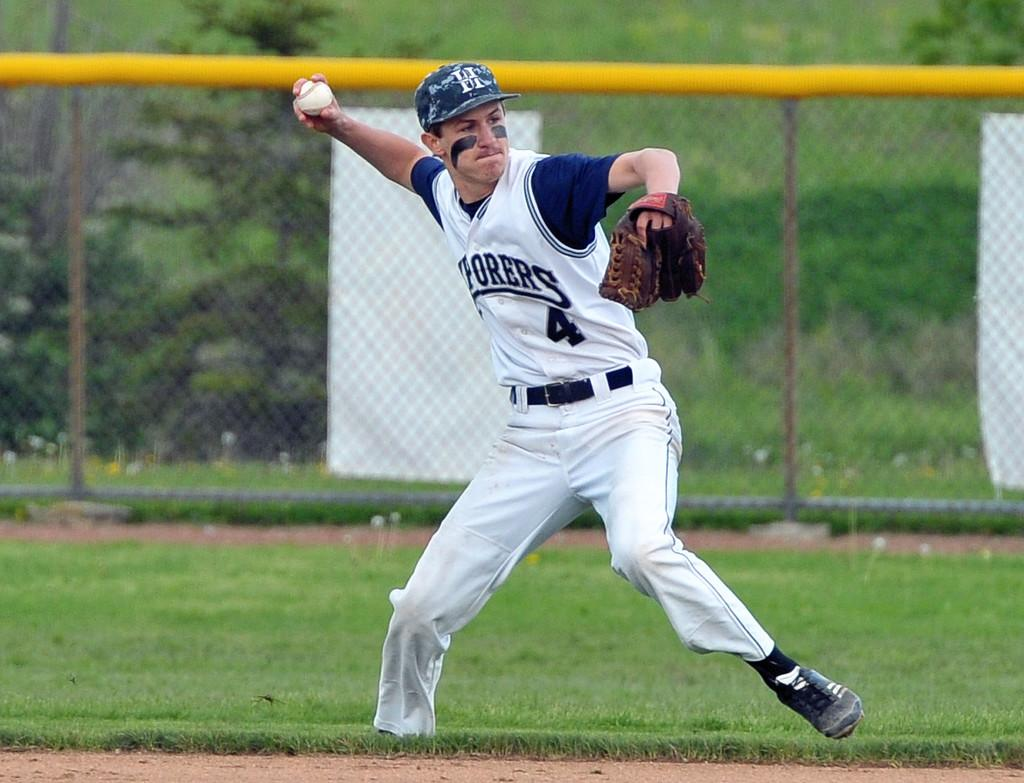<image>
Render a clear and concise summary of the photo. A baseball player wearing jersey number 4 gets ready to throw the ball. 